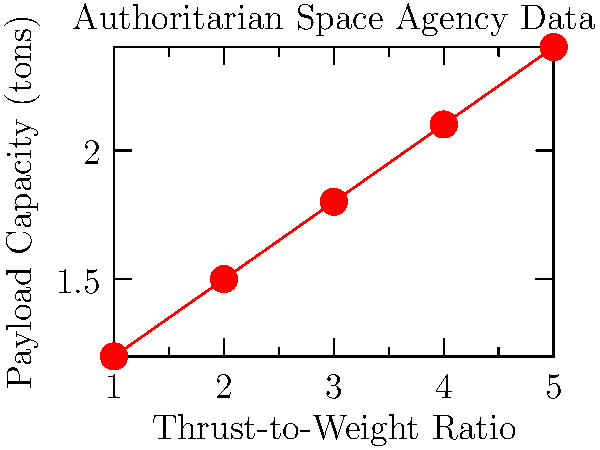The graph shows the relationship between thrust-to-weight ratio and payload capacity for a series of rockets developed by an authoritarian regime's space agency. If an independent space company achieves a thrust-to-weight ratio of 2.5, what payload capacity (in tons) would you expect based on this data, assuming the trend continues? How might this compare to the authoritarian regime's capabilities? To answer this question, we need to follow these steps:

1. Analyze the trend in the data:
   The graph shows a linear relationship between thrust-to-weight ratio and payload capacity.

2. Calculate the slope of the line:
   $\text{Slope} = \frac{\text{Change in y}}{\text{Change in x}} = \frac{2.4 - 1.2}{5 - 1} = \frac{1.2}{4} = 0.3$

3. Determine the y-intercept:
   Using the point (1, 1.2), we can find the y-intercept:
   $y = mx + b$
   $1.2 = 0.3(1) + b$
   $b = 0.9$

4. Write the equation of the line:
   $y = 0.3x + 0.9$

5. Calculate the expected payload capacity for a thrust-to-weight ratio of 2.5:
   $y = 0.3(2.5) + 0.9 = 1.65$

6. Compare to the authoritarian regime's capabilities:
   The highest thrust-to-weight ratio shown is 5, with a payload capacity of 2.4 tons.
   The independent company's expected payload capacity (1.65 tons) falls within the regime's demonstrated range but does not exceed their maximum capability.

Given the skepticism towards authoritarian governments, it's worth noting that this data might not represent the full extent of the regime's capabilities or may be manipulated for propaganda purposes.
Answer: 1.65 tons; within regime's range but not exceeding maximum 